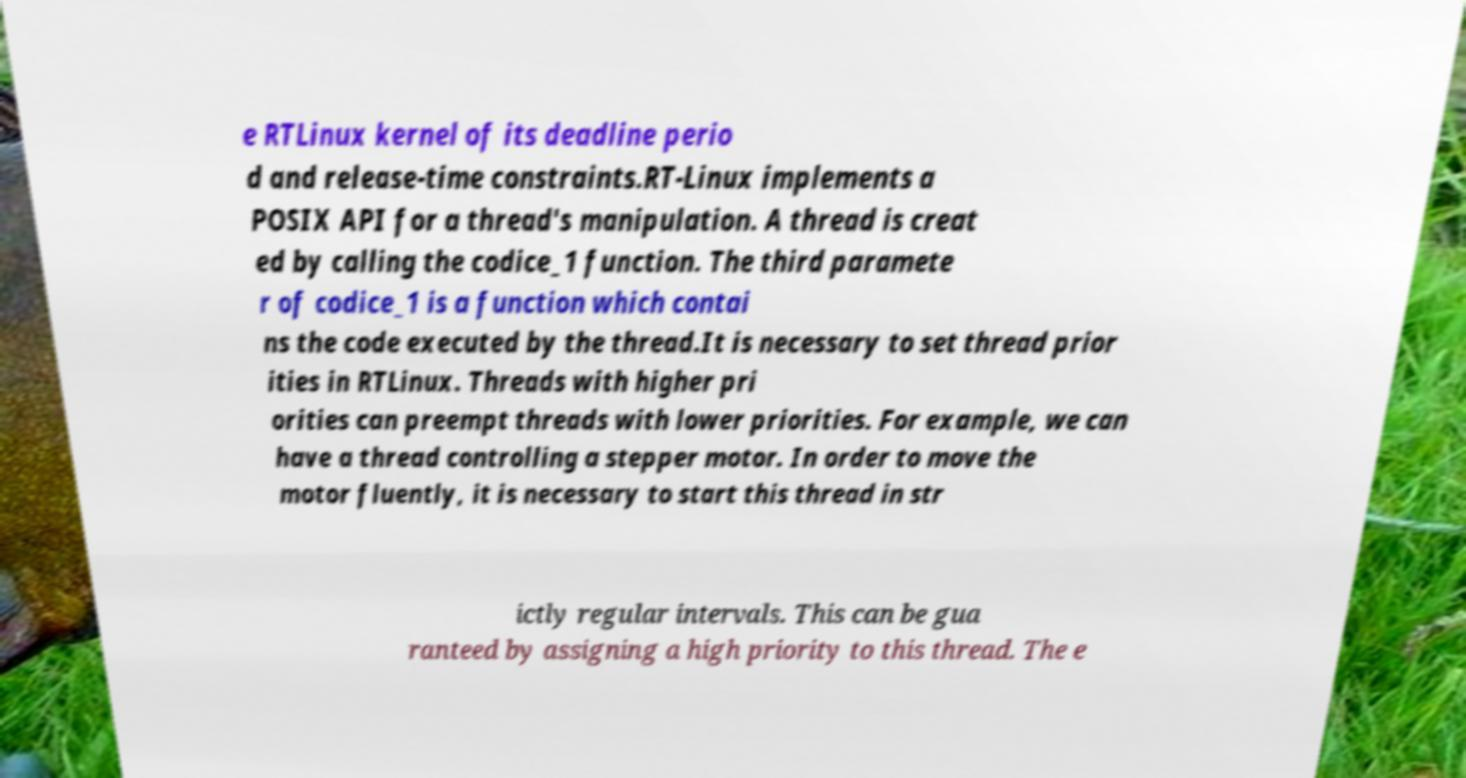There's text embedded in this image that I need extracted. Can you transcribe it verbatim? e RTLinux kernel of its deadline perio d and release-time constraints.RT-Linux implements a POSIX API for a thread's manipulation. A thread is creat ed by calling the codice_1 function. The third paramete r of codice_1 is a function which contai ns the code executed by the thread.It is necessary to set thread prior ities in RTLinux. Threads with higher pri orities can preempt threads with lower priorities. For example, we can have a thread controlling a stepper motor. In order to move the motor fluently, it is necessary to start this thread in str ictly regular intervals. This can be gua ranteed by assigning a high priority to this thread. The e 